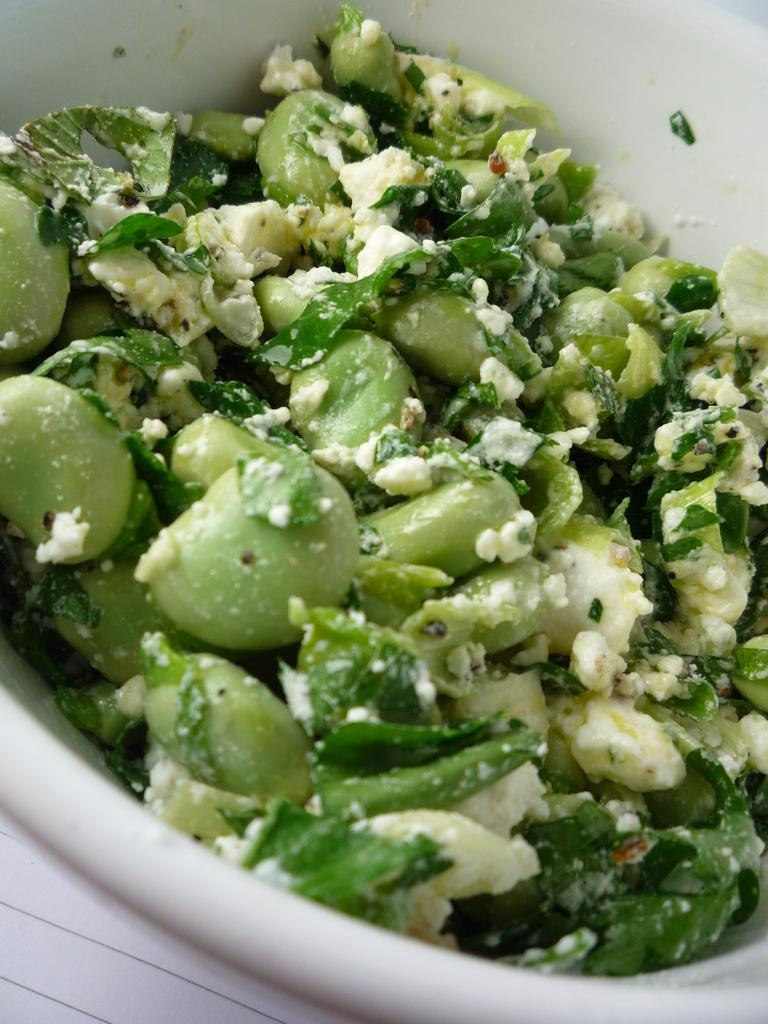What is in the bowl that is visible in the image? There is a bowl in the image, and it contains cooked green vegetable food items. Can you describe the contents of the bowl in more detail? The bowl contains cooked green vegetable food items, which are likely to be a type of vegetable dish. What type of car can be seen parked next to the bowl in the image? There is no car present in the image; it only features a bowl containing cooked green vegetable food items. Is there a lamp illuminating the bowl in the image? There is no lamp visible in the image; it only features a bowl containing cooked green vegetable food items. 